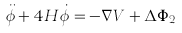<formula> <loc_0><loc_0><loc_500><loc_500>\ddot { \phi } + 4 H \dot { \phi } = - \nabla V + \Delta \Phi _ { 2 }</formula> 